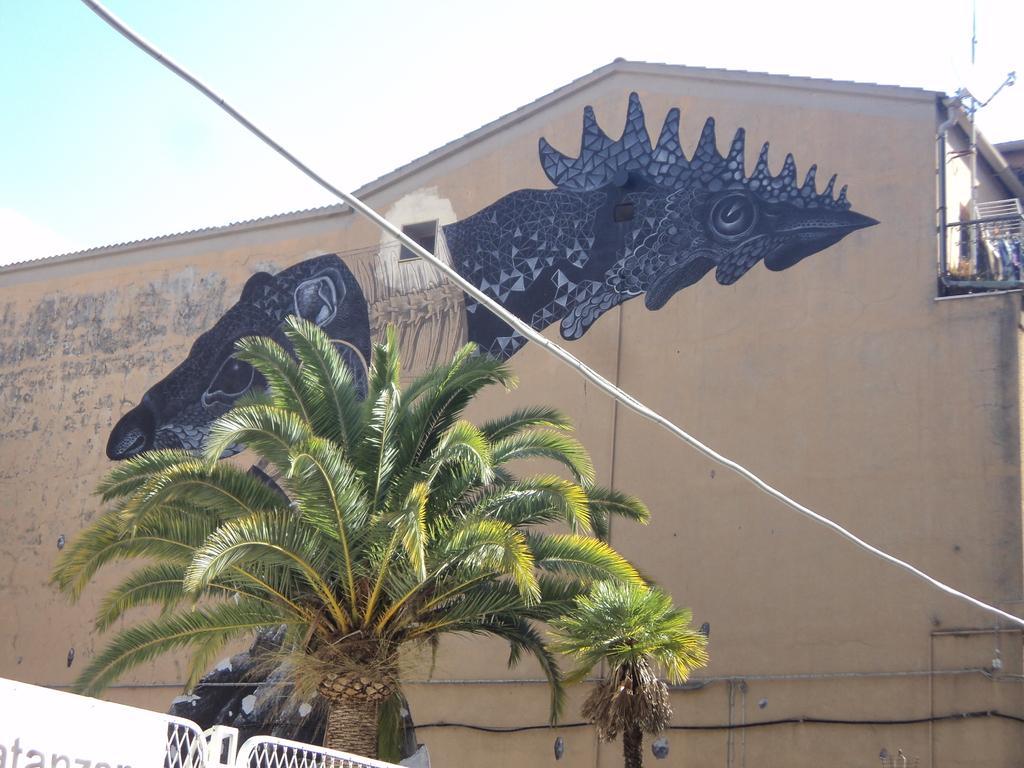Can you describe this image briefly? In this picture I can see there is an image of an animal on the wall, there is a building, a tree, fence and there is a white cable and the sky is clear. 